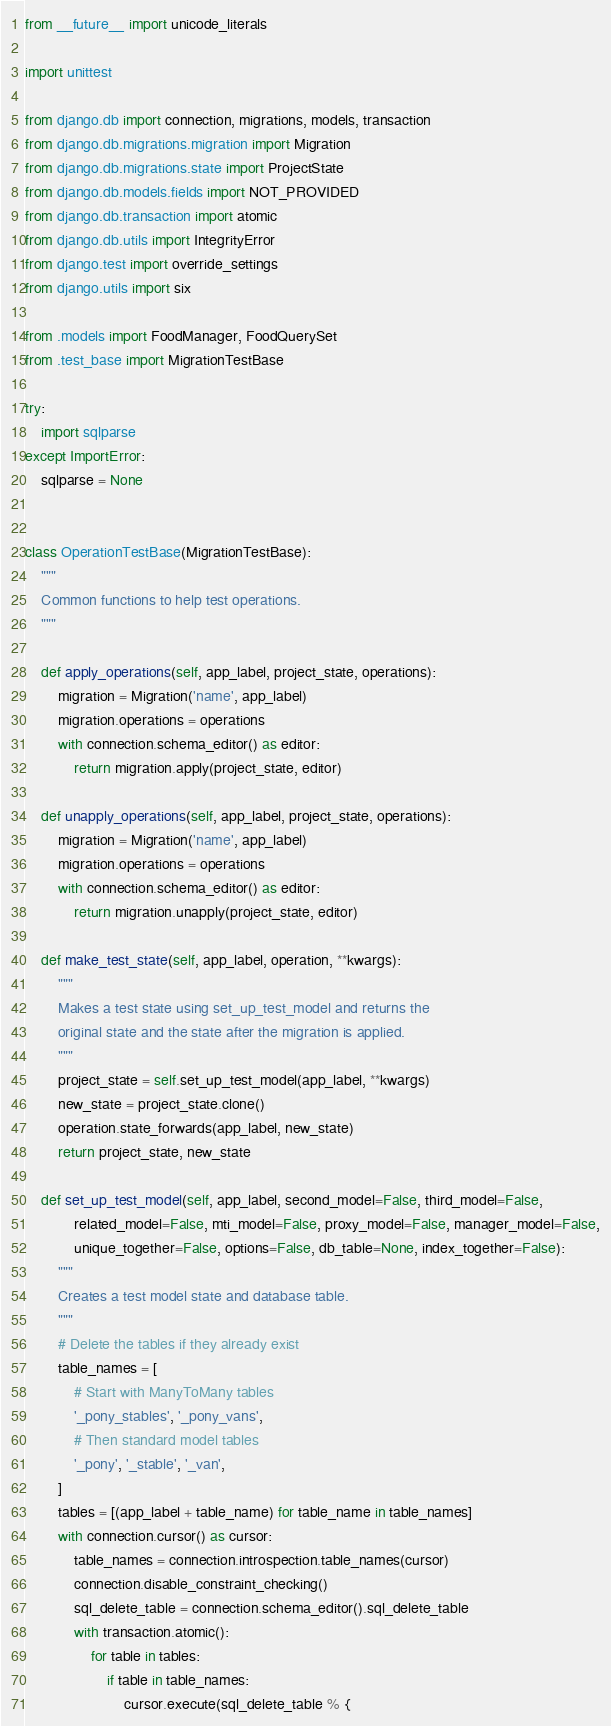Convert code to text. <code><loc_0><loc_0><loc_500><loc_500><_Python_>from __future__ import unicode_literals

import unittest

from django.db import connection, migrations, models, transaction
from django.db.migrations.migration import Migration
from django.db.migrations.state import ProjectState
from django.db.models.fields import NOT_PROVIDED
from django.db.transaction import atomic
from django.db.utils import IntegrityError
from django.test import override_settings
from django.utils import six

from .models import FoodManager, FoodQuerySet
from .test_base import MigrationTestBase

try:
    import sqlparse
except ImportError:
    sqlparse = None


class OperationTestBase(MigrationTestBase):
    """
    Common functions to help test operations.
    """

    def apply_operations(self, app_label, project_state, operations):
        migration = Migration('name', app_label)
        migration.operations = operations
        with connection.schema_editor() as editor:
            return migration.apply(project_state, editor)

    def unapply_operations(self, app_label, project_state, operations):
        migration = Migration('name', app_label)
        migration.operations = operations
        with connection.schema_editor() as editor:
            return migration.unapply(project_state, editor)

    def make_test_state(self, app_label, operation, **kwargs):
        """
        Makes a test state using set_up_test_model and returns the
        original state and the state after the migration is applied.
        """
        project_state = self.set_up_test_model(app_label, **kwargs)
        new_state = project_state.clone()
        operation.state_forwards(app_label, new_state)
        return project_state, new_state

    def set_up_test_model(self, app_label, second_model=False, third_model=False,
            related_model=False, mti_model=False, proxy_model=False, manager_model=False,
            unique_together=False, options=False, db_table=None, index_together=False):
        """
        Creates a test model state and database table.
        """
        # Delete the tables if they already exist
        table_names = [
            # Start with ManyToMany tables
            '_pony_stables', '_pony_vans',
            # Then standard model tables
            '_pony', '_stable', '_van',
        ]
        tables = [(app_label + table_name) for table_name in table_names]
        with connection.cursor() as cursor:
            table_names = connection.introspection.table_names(cursor)
            connection.disable_constraint_checking()
            sql_delete_table = connection.schema_editor().sql_delete_table
            with transaction.atomic():
                for table in tables:
                    if table in table_names:
                        cursor.execute(sql_delete_table % {</code> 